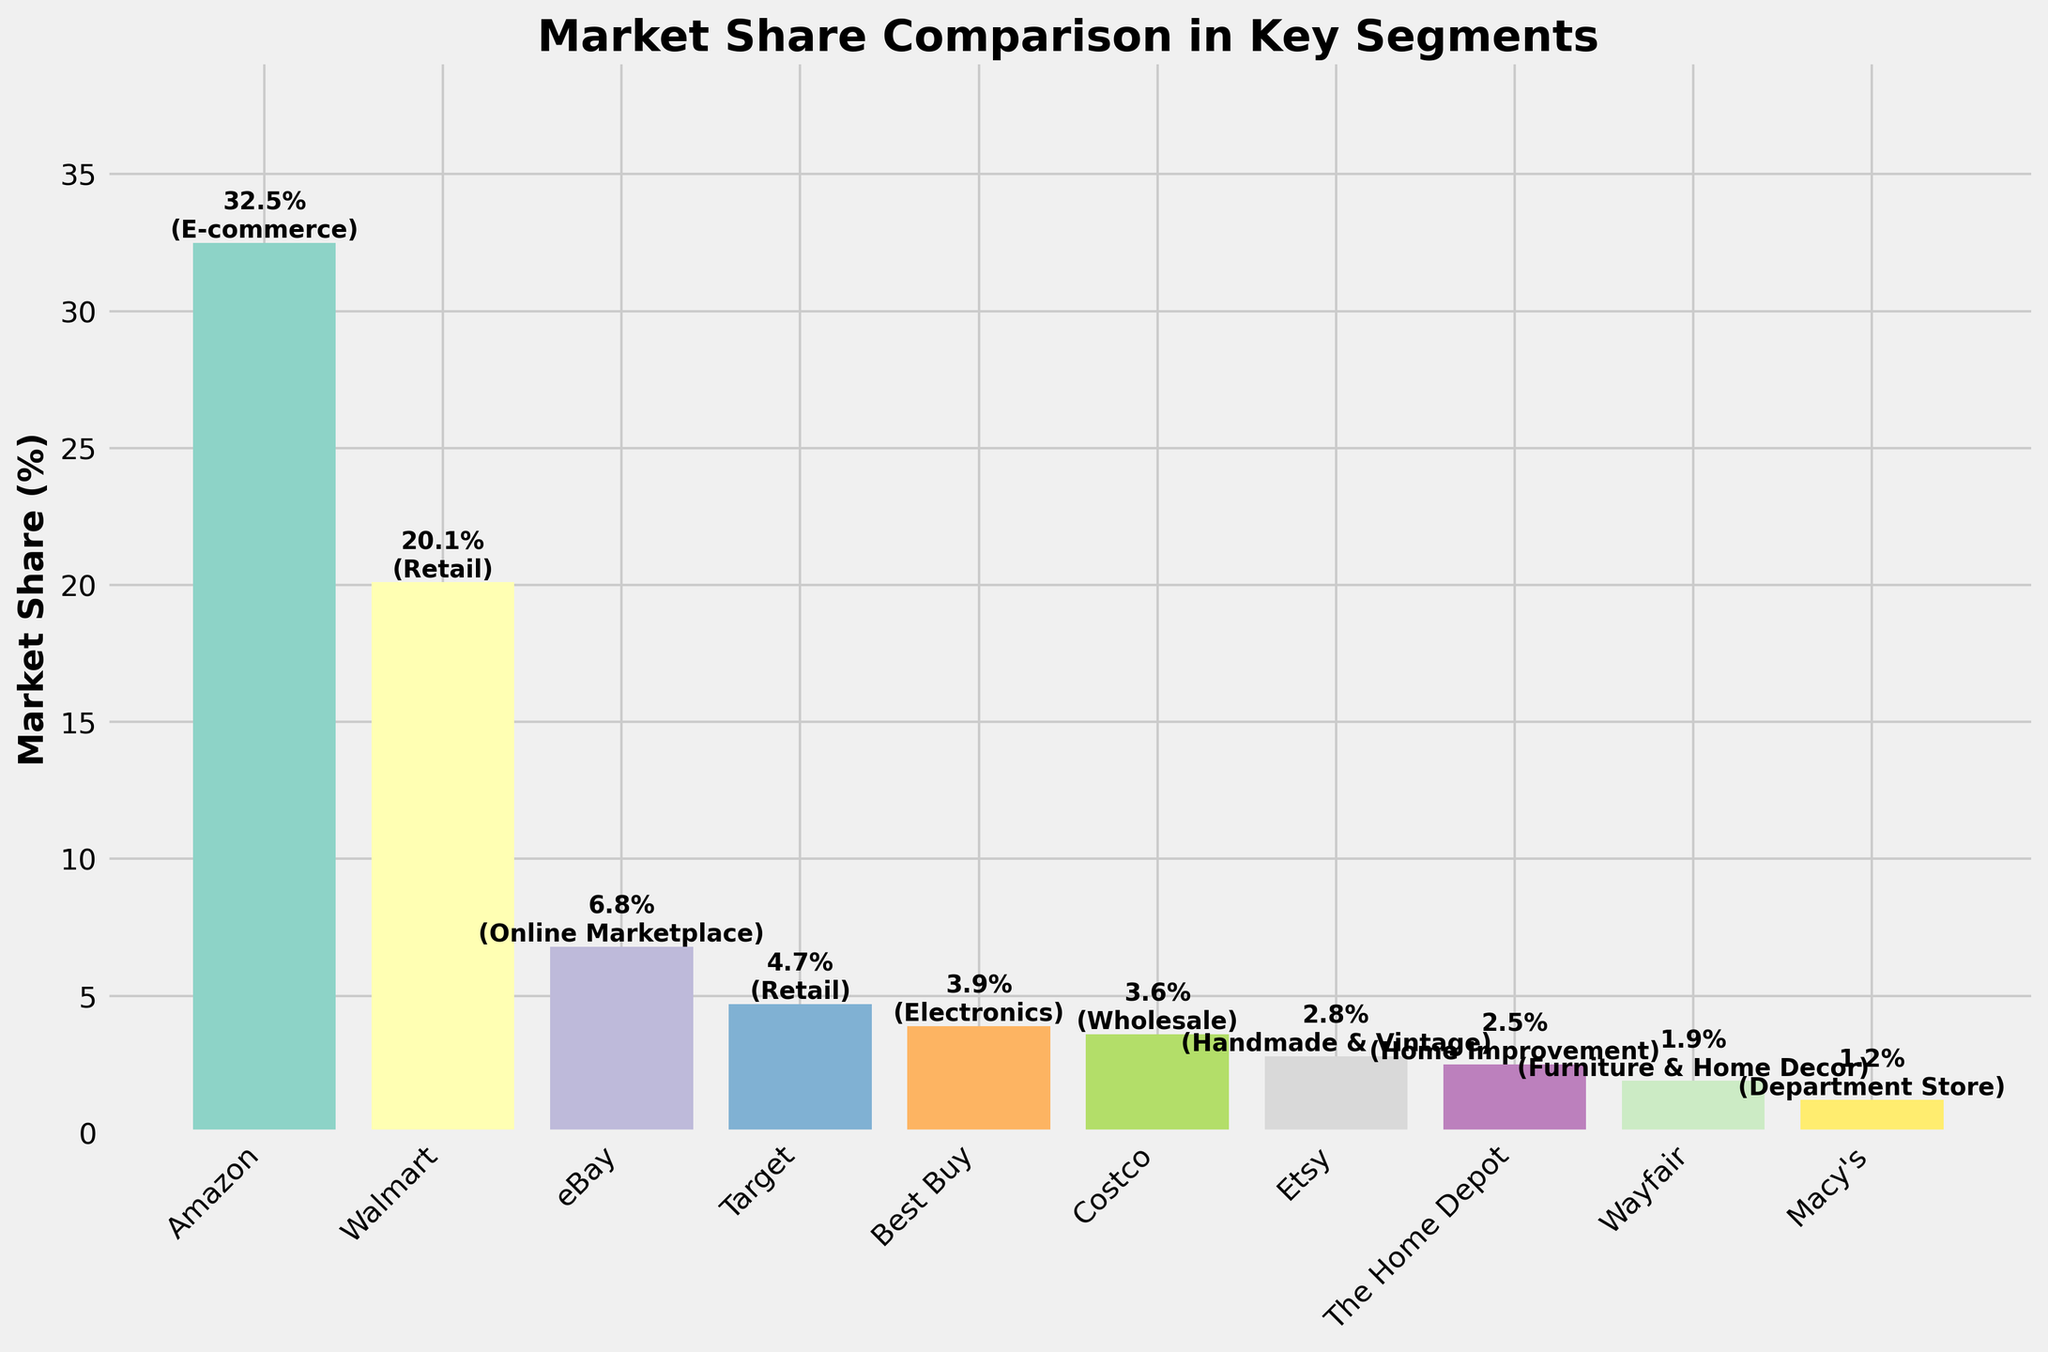what's the combined market share of Walmart and Target? Add the market share of Walmart (20.1%) and Target (4.7%). Therefore, 20.1% + 4.7% = 24.8%.
Answer: 24.8% which company has a higher market share in retail, Walmart or Target? In the retail segment, Walmart has 20.1% market share and Target has 4.7%. Clearly, Walmart has a higher market share.
Answer: Walmart how much more market share does Amazon have compared to eBay? Subtract the market share of eBay (6.8%) from Amazon's market share (32.5%). Therefore, 32.5% - 6.8% = 25.7%.
Answer: 25.7% what's the difference in market share between the company with the highest and lowest market share? Amazon has the highest market share at 32.5% and Macy's has the lowest at 1.2%. Therefore, 32.5% - 1.2% = 31.3%.
Answer: 31.3% what's the average market share of the companies listed? Add all the market shares: 32.5% + 20.1% + 6.8% + 4.7% + 3.9% + 3.6% + 2.8% + 2.5% + 1.9% + 1.2% = 80. Fore there are 10 companies, the average is 80/10 = 8%.
Answer: 8% which company is the largest in the electronics segment? Based on the text in the bars, Best Buy is the only company listed in the electronics segment with a market share of 3.9%.
Answer: Best Buy how does Costco's market share compare to Best Buy's? Costco's market share is 3.6%, and Best Buy's is 3.9%. Therefore, Best Buy's market share is 0.3% higher than Costco's.
Answer: Best Buy which segment is represented by the greatest range of companies? The retail segment includes both Walmart and Target. No other segment has more than one company listed.
Answer: Retail what's the total market share of companies in the retail segment? Add the market shares of Walmart (20.1%) and Target (4.7%). Therefore, 20.1% + 4.7% = 24.8%.
Answer: 24.8% which companies have a market share below 3%? The companies with market shares below 3% are Etsy (2.8%), The Home Depot (2.5%), Wayfair (1.9%), and Macy's (1.2%).
Answer: Etsy, The Home Depot, Wayfair, Macy's 